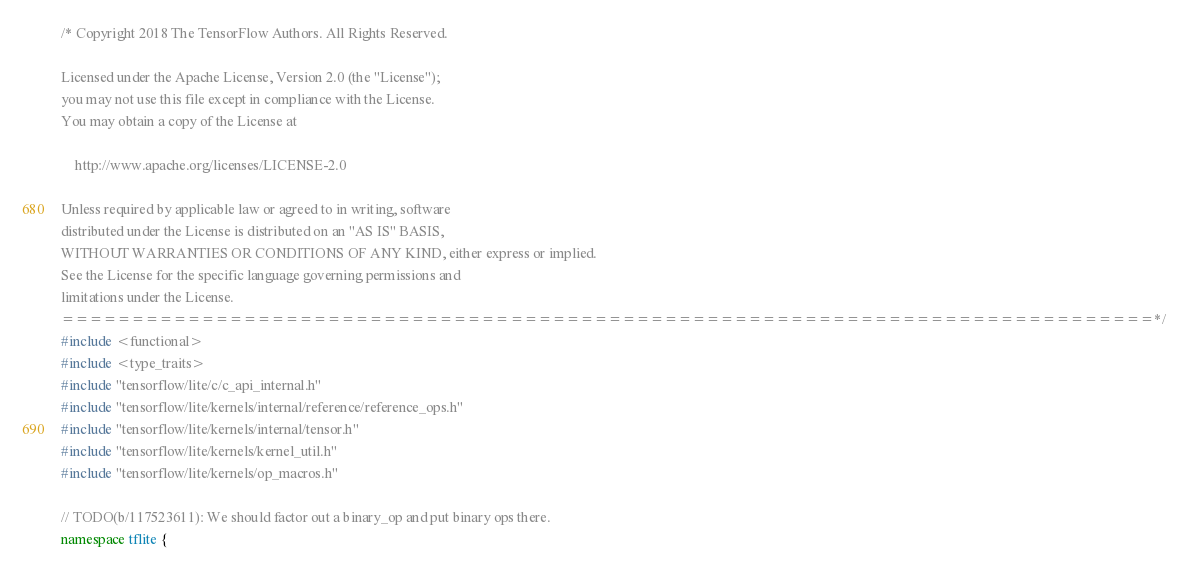Convert code to text. <code><loc_0><loc_0><loc_500><loc_500><_C++_>/* Copyright 2018 The TensorFlow Authors. All Rights Reserved.

Licensed under the Apache License, Version 2.0 (the "License");
you may not use this file except in compliance with the License.
You may obtain a copy of the License at

    http://www.apache.org/licenses/LICENSE-2.0

Unless required by applicable law or agreed to in writing, software
distributed under the License is distributed on an "AS IS" BASIS,
WITHOUT WARRANTIES OR CONDITIONS OF ANY KIND, either express or implied.
See the License for the specific language governing permissions and
limitations under the License.
==============================================================================*/
#include <functional>
#include <type_traits>
#include "tensorflow/lite/c/c_api_internal.h"
#include "tensorflow/lite/kernels/internal/reference/reference_ops.h"
#include "tensorflow/lite/kernels/internal/tensor.h"
#include "tensorflow/lite/kernels/kernel_util.h"
#include "tensorflow/lite/kernels/op_macros.h"

// TODO(b/117523611): We should factor out a binary_op and put binary ops there.
namespace tflite {</code> 